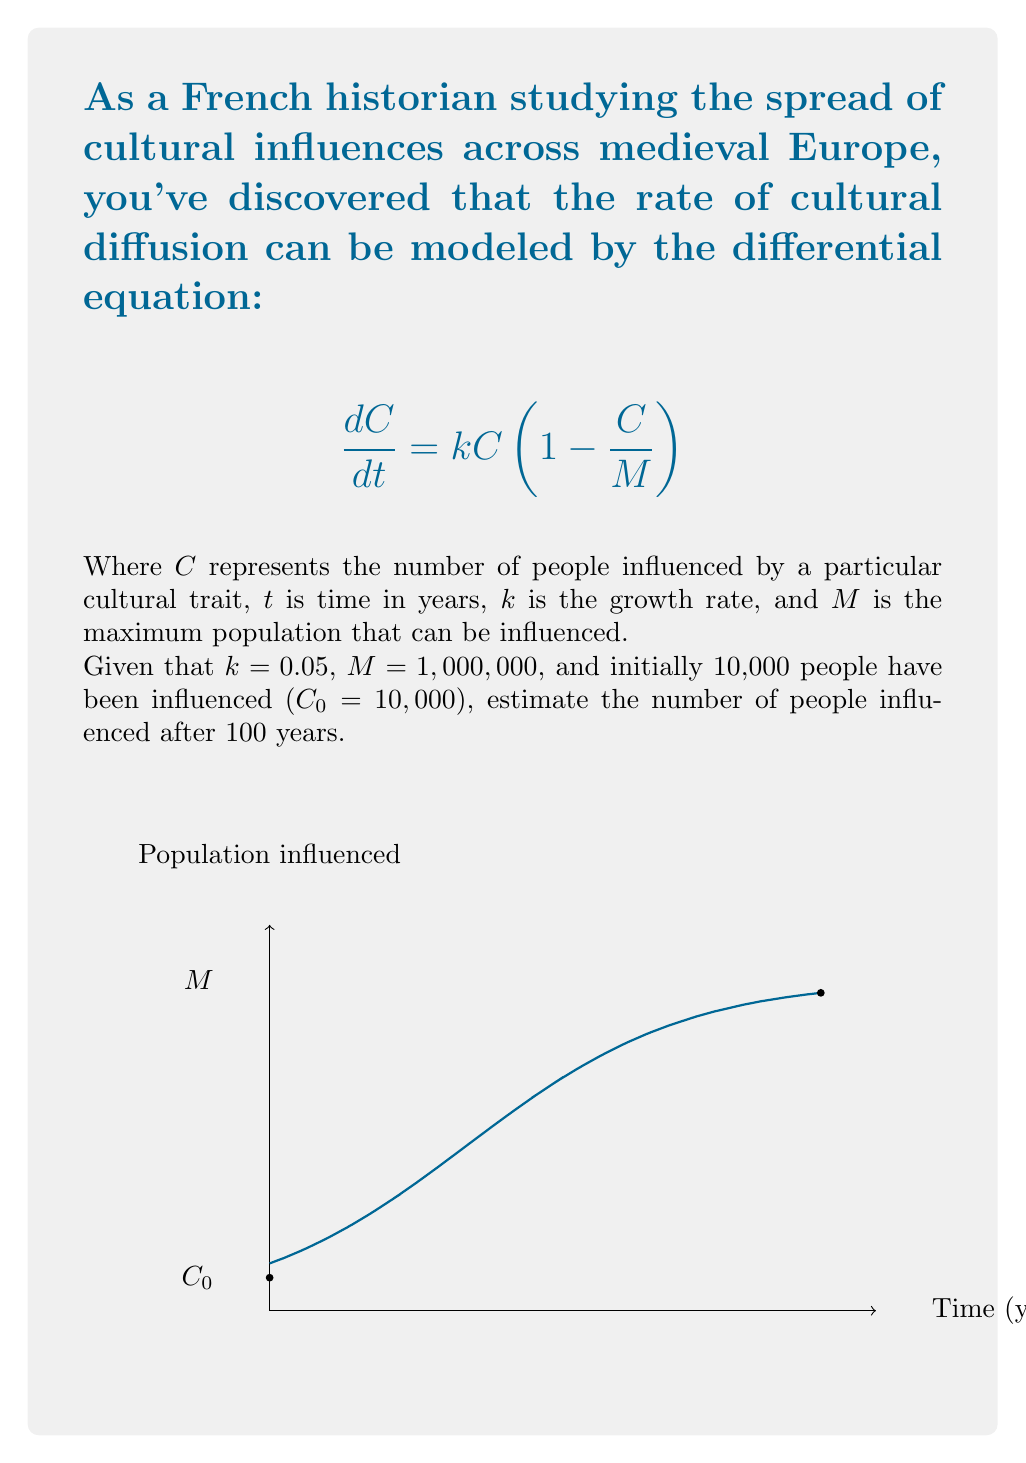Could you help me with this problem? To solve this problem, we'll follow these steps:

1) The given differential equation is a logistic growth model. Its solution is:

   $$C(t) = \frac{M}{1 + (\frac{M}{C_0} - 1)e^{-kt}}$$

2) We're given:
   $k = 0.05$
   $M = 1,000,000$
   $C_0 = 10,000$
   $t = 100$

3) Let's substitute these values into our equation:

   $$C(100) = \frac{1,000,000}{1 + (\frac{1,000,000}{10,000} - 1)e^{-0.05(100)}}$$

4) Simplify:
   $$C(100) = \frac{1,000,000}{1 + (99)e^{-5}}$$

5) Calculate $e^{-5}$:
   $$e^{-5} \approx 0.00674$$

6) Now our equation looks like:
   $$C(100) = \frac{1,000,000}{1 + 99(0.00674)}$$

7) Simplify:
   $$C(100) = \frac{1,000,000}{1 + 0.66726}$$
   $$C(100) = \frac{1,000,000}{1.66726}$$

8) Calculate the final result:
   $$C(100) \approx 599,786$$

Therefore, after 100 years, approximately 599,786 people would be influenced by the cultural trait.
Answer: 599,786 people 